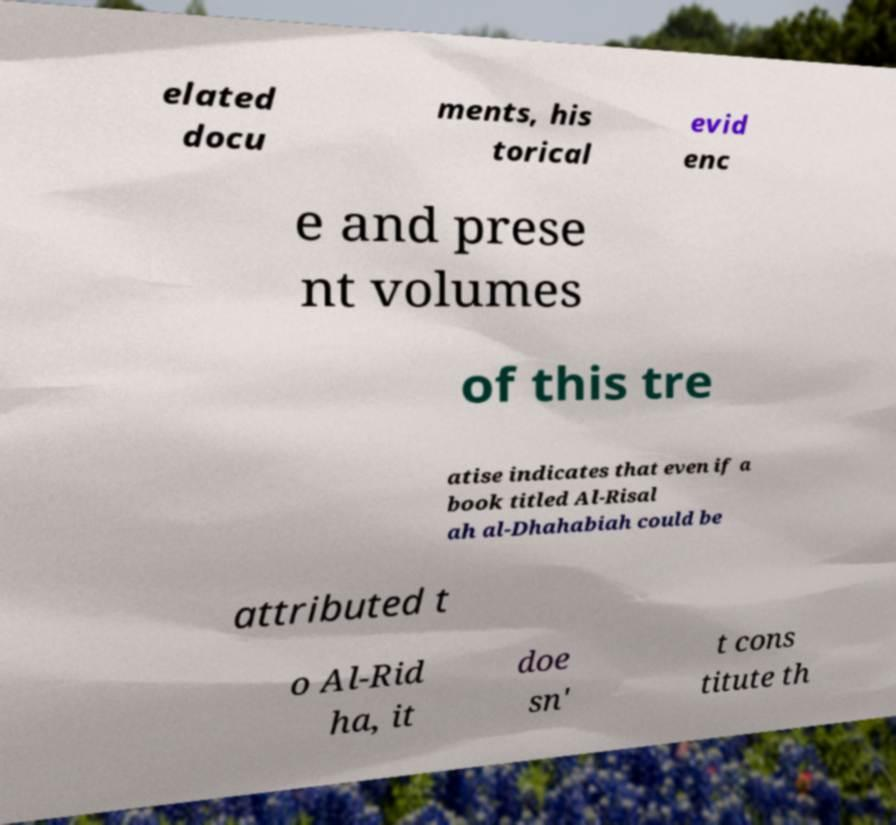What messages or text are displayed in this image? I need them in a readable, typed format. elated docu ments, his torical evid enc e and prese nt volumes of this tre atise indicates that even if a book titled Al-Risal ah al-Dhahabiah could be attributed t o Al-Rid ha, it doe sn' t cons titute th 